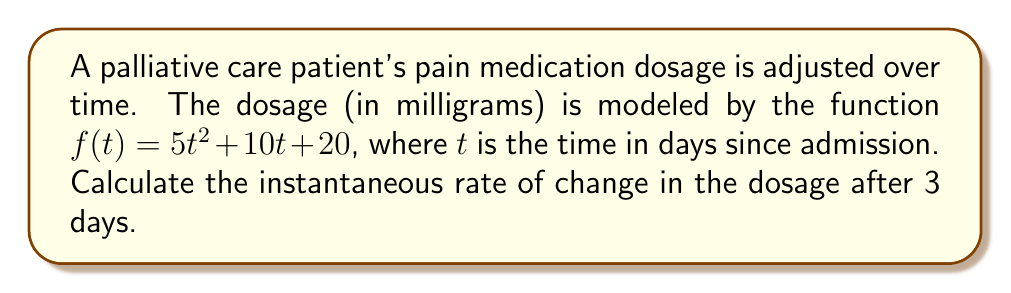Provide a solution to this math problem. To find the instantaneous rate of change, we need to calculate the derivative of the function $f(t)$ and then evaluate it at $t = 3$.

1) First, let's find the derivative of $f(t)$:
   $f(t) = 5t^2 + 10t + 20$
   $f'(t) = 10t + 10$ (using the power rule and constant rule of differentiation)

2) Now, we need to evaluate $f'(t)$ at $t = 3$:
   $f'(3) = 10(3) + 10$
   $f'(3) = 30 + 10 = 40$

3) The units of the rate of change will be milligrams per day (mg/day), as we're measuring how the dosage (in mg) changes with respect to time (in days).

Therefore, the instantaneous rate of change in the dosage after 3 days is 40 mg/day.
Answer: 40 mg/day 